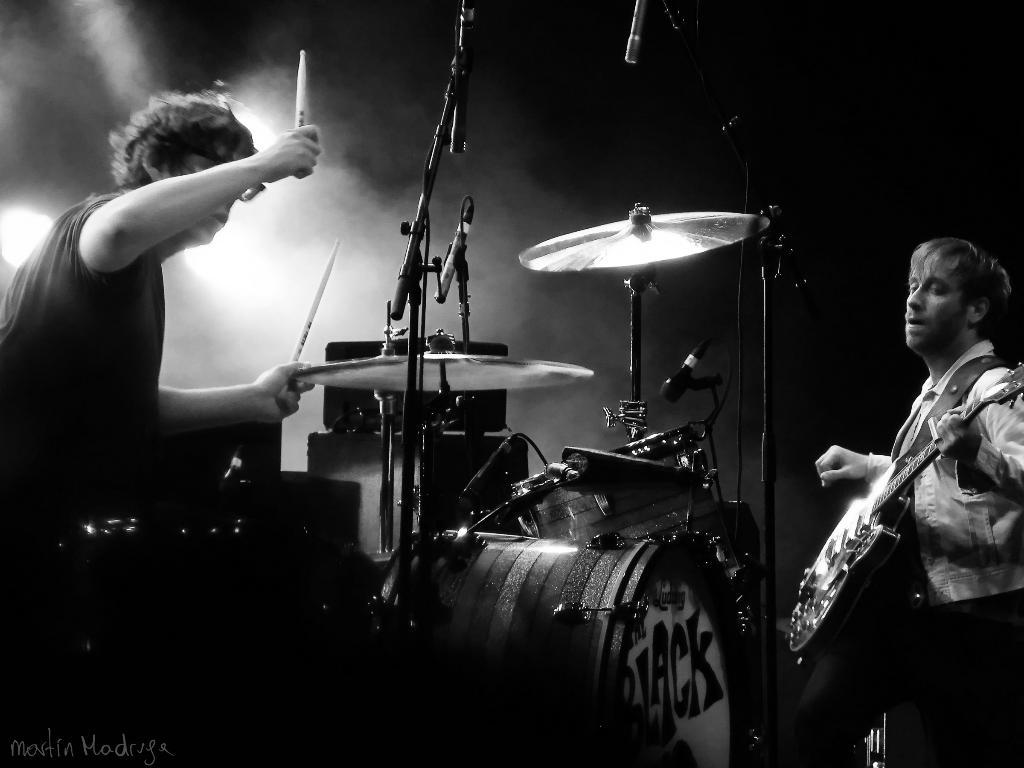How many musicians are present in the image? There are 2 musicians in the image. What instruments are the musicians playing? One musician is playing drums, and the other musician is playing a guitar. What is the drummer holding? The drummer holds sticks. What is the purpose of the microphone in the image? The microphone is a musical instrument accessory. Is there any destruction caused by a river in the image? There is no river or any indication of destruction present in the image. Can you see any baseball equipment in the image? There is no baseball equipment visible in the image. 